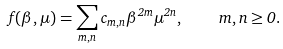<formula> <loc_0><loc_0><loc_500><loc_500>f ( \beta , \mu ) = \sum _ { m , n } c _ { m , n } \beta ^ { 2 m } \mu ^ { 2 n } , \quad m , n \geq 0 .</formula> 